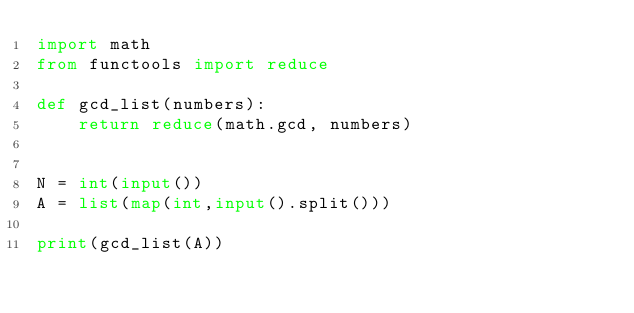Convert code to text. <code><loc_0><loc_0><loc_500><loc_500><_Python_>import math
from functools import reduce

def gcd_list(numbers):
    return reduce(math.gcd, numbers)


N = int(input())
A = list(map(int,input().split()))

print(gcd_list(A))</code> 